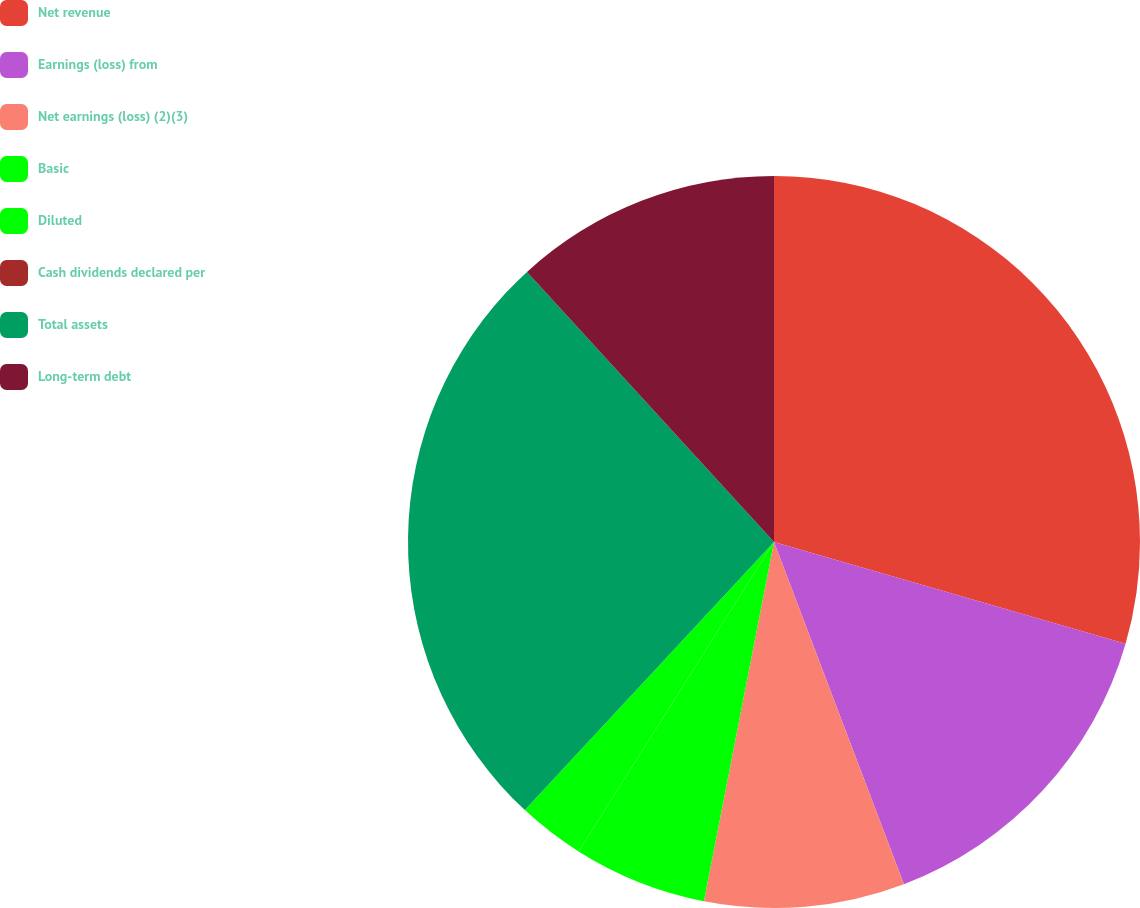Convert chart. <chart><loc_0><loc_0><loc_500><loc_500><pie_chart><fcel>Net revenue<fcel>Earnings (loss) from<fcel>Net earnings (loss) (2)(3)<fcel>Basic<fcel>Diluted<fcel>Cash dividends declared per<fcel>Total assets<fcel>Long-term debt<nl><fcel>29.48%<fcel>14.74%<fcel>8.84%<fcel>5.9%<fcel>2.95%<fcel>0.0%<fcel>26.29%<fcel>11.79%<nl></chart> 